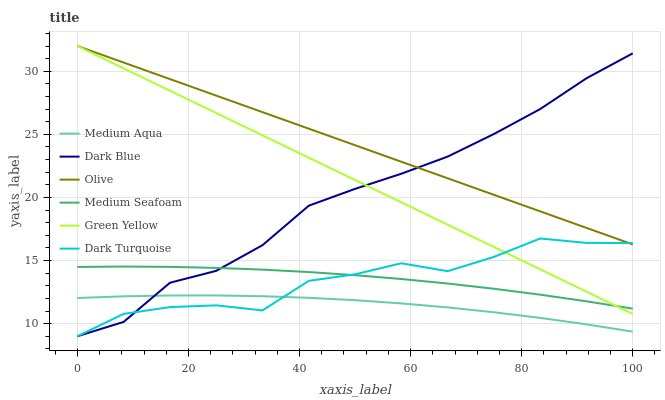Does Medium Aqua have the minimum area under the curve?
Answer yes or no. Yes. Does Olive have the maximum area under the curve?
Answer yes or no. Yes. Does Dark Blue have the minimum area under the curve?
Answer yes or no. No. Does Dark Blue have the maximum area under the curve?
Answer yes or no. No. Is Green Yellow the smoothest?
Answer yes or no. Yes. Is Dark Turquoise the roughest?
Answer yes or no. Yes. Is Dark Blue the smoothest?
Answer yes or no. No. Is Dark Blue the roughest?
Answer yes or no. No. Does Dark Turquoise have the lowest value?
Answer yes or no. Yes. Does Medium Aqua have the lowest value?
Answer yes or no. No. Does Green Yellow have the highest value?
Answer yes or no. Yes. Does Dark Blue have the highest value?
Answer yes or no. No. Is Medium Aqua less than Olive?
Answer yes or no. Yes. Is Olive greater than Medium Seafoam?
Answer yes or no. Yes. Does Olive intersect Dark Blue?
Answer yes or no. Yes. Is Olive less than Dark Blue?
Answer yes or no. No. Is Olive greater than Dark Blue?
Answer yes or no. No. Does Medium Aqua intersect Olive?
Answer yes or no. No. 